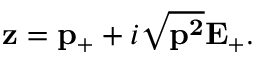Convert formula to latex. <formula><loc_0><loc_0><loc_500><loc_500>{ z } = { p } _ { + } + i \sqrt { { p ^ { 2 } } } { E } _ { + } .</formula> 